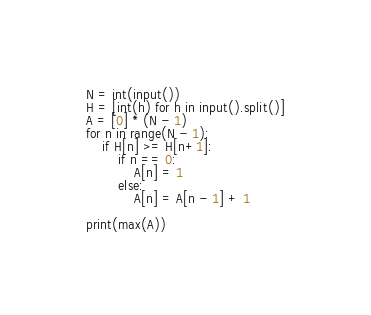Convert code to text. <code><loc_0><loc_0><loc_500><loc_500><_Python_>N = int(input())
H = [int(h) for h in input().split()]
A = [0] * (N - 1)
for n in range(N - 1):
    if H[n] >= H[n+1]:
        if n == 0:
            A[n] = 1
        else:
            A[n] = A[n - 1] + 1

print(max(A))</code> 